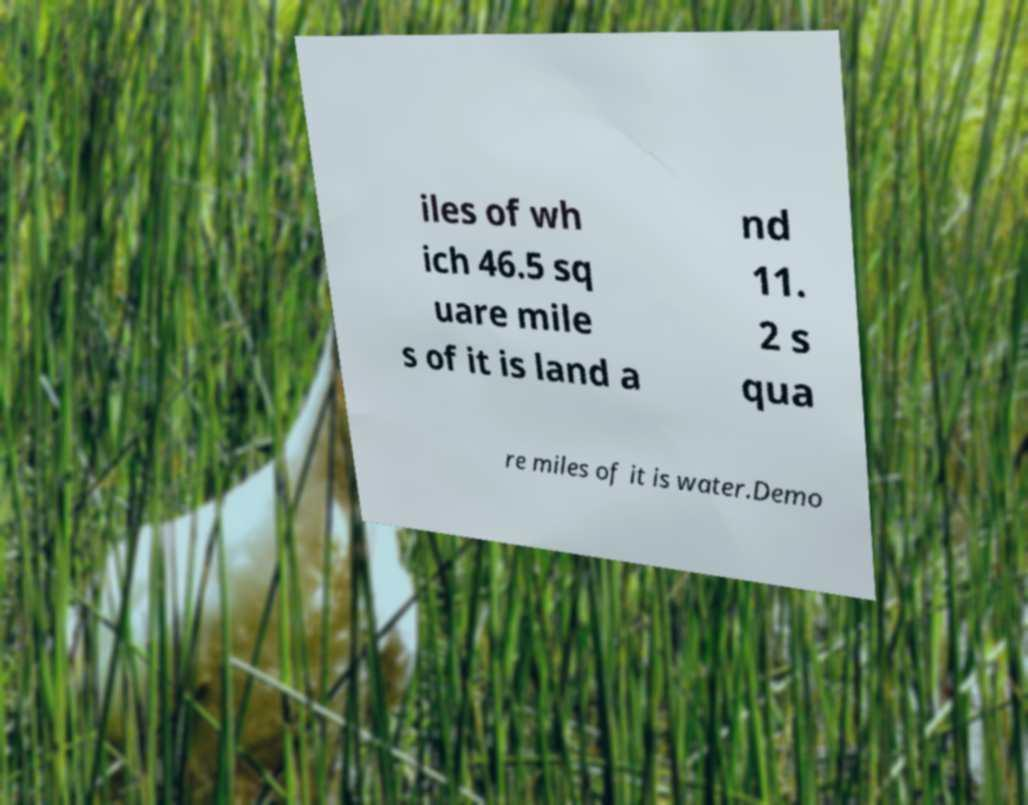Please read and relay the text visible in this image. What does it say? iles of wh ich 46.5 sq uare mile s of it is land a nd 11. 2 s qua re miles of it is water.Demo 